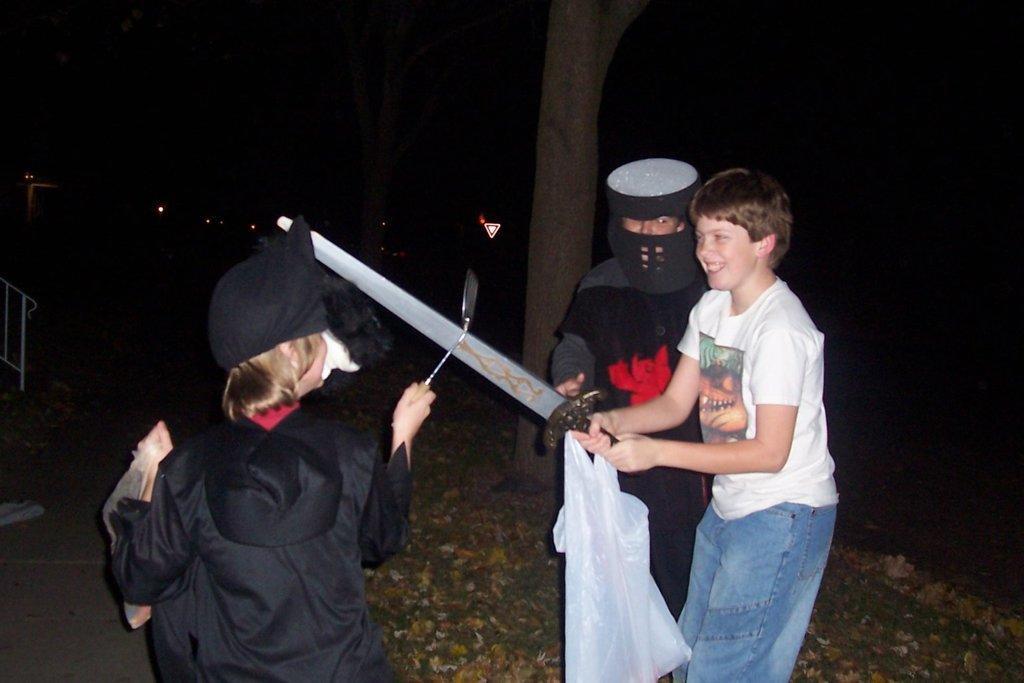Could you give a brief overview of what you see in this image? In this picture there is a boy standing and holding the cover and sword and there is a person standing and holding the spoon and there is a boy standing. At the back there are trees and there is a railing. At the bottom there is a road and there are dried leaves on the grass. 